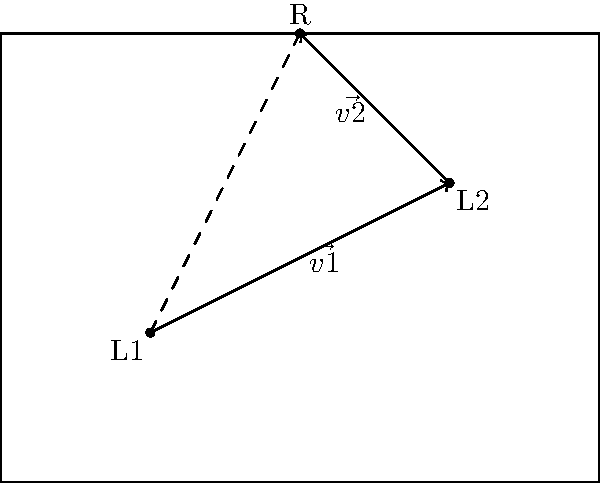In a rectangular room measuring 4m by 3m, you need to determine the optimal placement for a chandelier. Two existing light fixtures, L1 and L2, are located at (1,1) and (3,2) respectively. The client wants the chandelier to be positioned such that it balances the lighting from both fixtures. Given that the vector $\vec{v1}$ represents a 2m shift east and 1m shift north from L1, and $\vec{v2}$ represents a 1m shift west and 1m shift north from L2, where should the chandelier (R) be placed to achieve optimal lighting balance? To find the optimal placement for the chandelier, we need to use vector addition to determine the resultant vector. Here's how we can solve this problem step by step:

1. Identify the given vectors:
   $\vec{v1} = (2, 1)$
   $\vec{v2} = (-1, 1)$

2. Add the vectors:
   $\vec{v_{resultant}} = \vec{v1} + \vec{v2} = (2, 1) + (-1, 1) = (1, 2)$

3. The resultant vector $(1, 2)$ represents the displacement from L1 to the optimal chandelier position (R).

4. Calculate the coordinates of R by adding the resultant vector to the coordinates of L1:
   $R = L1 + \vec{v_{resultant}} = (1, 1) + (1, 2) = (2, 3)$

5. Verify that this position also satisfies the condition from L2:
   $L2 + \vec{v2} = (3, 2) + (-1, 1) = (2, 3)$

Therefore, the optimal placement for the chandelier (R) is at the coordinates (2, 3) in the room.
Answer: (2, 3) 